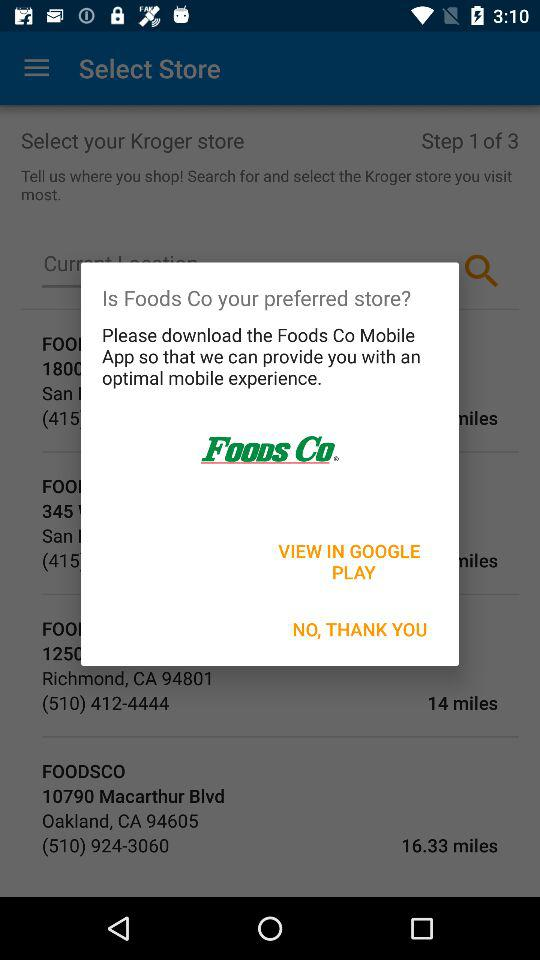Where can "Foods Co" be viewed? It can be viewed on "GOOGLE PLAY". 